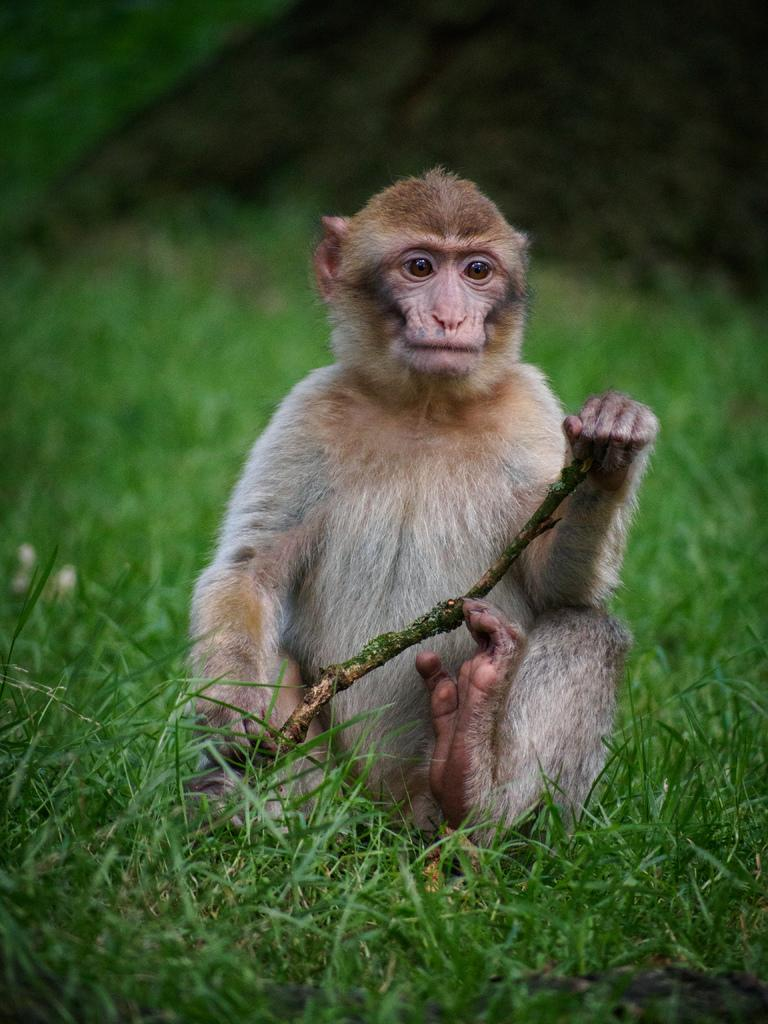What type of vegetation is at the bottom of the image? There is grass at the bottom of the image. What animal is in the middle of the image? A monkey is sitting in the middle of the image. What is the monkey holding in the image? The monkey is holding a stick. Can you describe the top of the image? The top of the image is blurry. Where is the army located in the image? There is no army present in the image. What type of mailbox can be seen near the monkey in the image? There is no mailbox present in the image. 